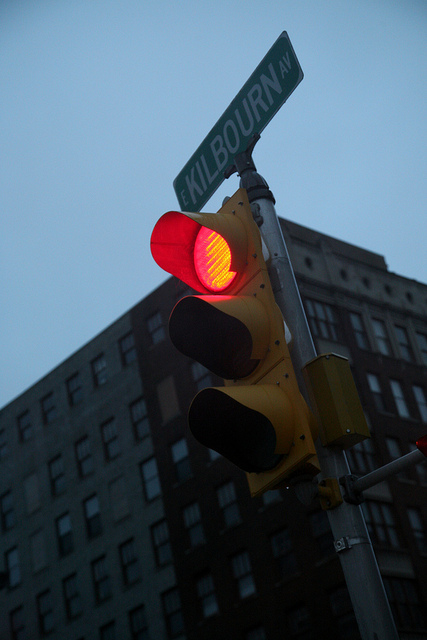Read and extract the text from this image. KILBOURN 